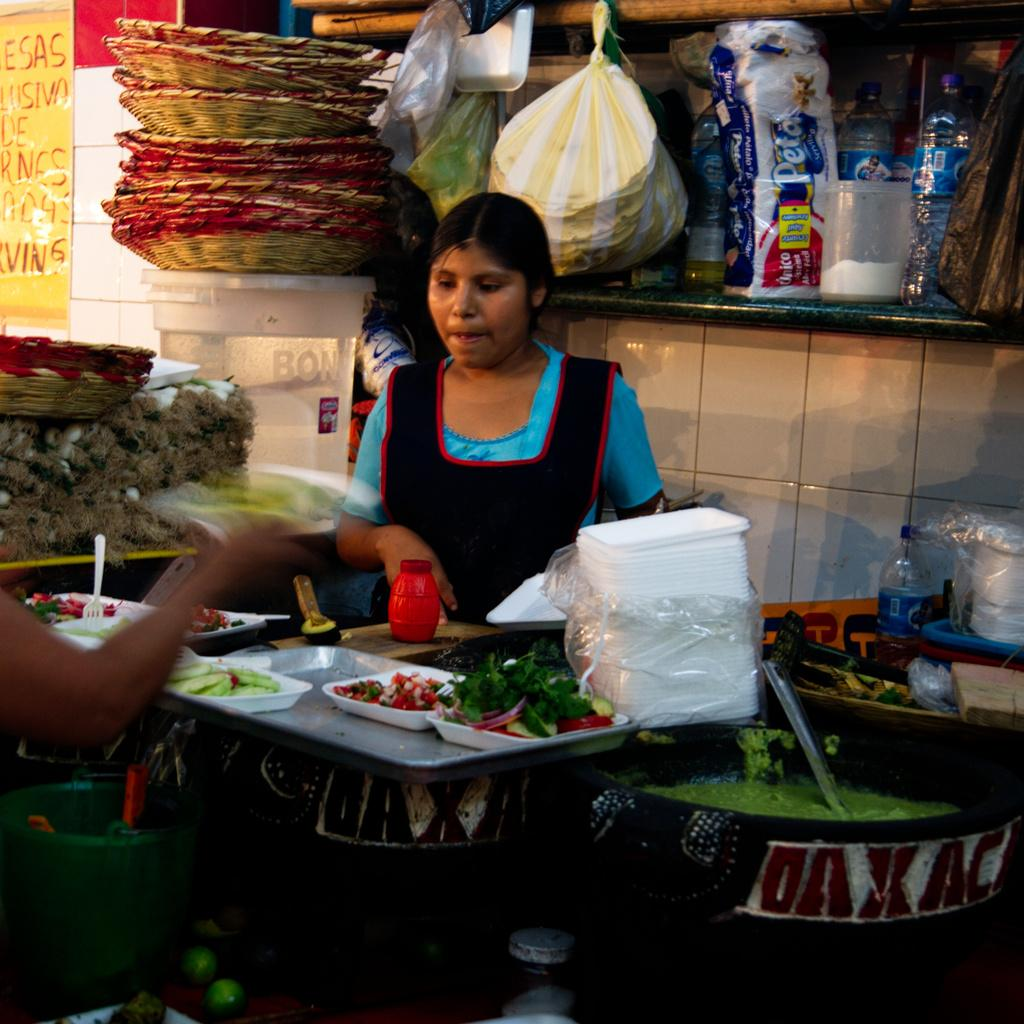How many people are present in the image? There are two people standing opposite each other in the image. What object is present in the image that is typically used for serving food? There is a plastic plate in the image. What is on the plate? There is food on the plate. What utensil is present in the image that is commonly used for eating? There is a spoon in the image. What type of beverage container is present in the image? There is a bottle in the image. What type of container is present in the image that is typically used for storing or transporting food or other items? There is a container in the image. What type of notebook is being used by one of the people in the image? There is no notebook present in the image. 